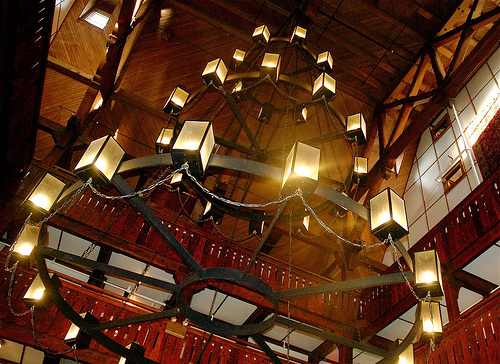<image>
Is there a building behind the light? No. The building is not behind the light. From this viewpoint, the building appears to be positioned elsewhere in the scene. Where is the light in relation to the celing? Is it in front of the celing? No. The light is not in front of the celing. The spatial positioning shows a different relationship between these objects. 